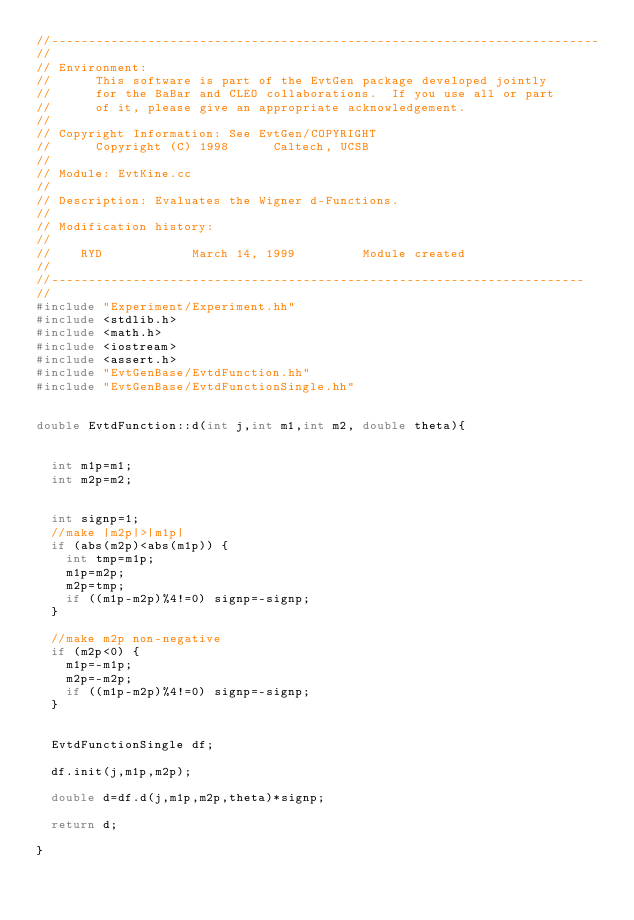Convert code to text. <code><loc_0><loc_0><loc_500><loc_500><_C++_>//--------------------------------------------------------------------------
//
// Environment:
//      This software is part of the EvtGen package developed jointly
//      for the BaBar and CLEO collaborations.  If you use all or part
//      of it, please give an appropriate acknowledgement.
//
// Copyright Information: See EvtGen/COPYRIGHT
//      Copyright (C) 1998      Caltech, UCSB
//
// Module: EvtKine.cc
//
// Description: Evaluates the Wigner d-Functions.
//
// Modification history:
//
//    RYD            March 14, 1999         Module created
//
//------------------------------------------------------------------------
// 
#include "Experiment/Experiment.hh"
#include <stdlib.h>
#include <math.h>
#include <iostream>
#include <assert.h>
#include "EvtGenBase/EvtdFunction.hh"
#include "EvtGenBase/EvtdFunctionSingle.hh"


double EvtdFunction::d(int j,int m1,int m2, double theta){


  int m1p=m1;
  int m2p=m2;


  int signp=1;
  //make |m2p|>|m1p|
  if (abs(m2p)<abs(m1p)) {
    int tmp=m1p;
    m1p=m2p;
    m2p=tmp;
    if ((m1p-m2p)%4!=0) signp=-signp;
  } 

  //make m2p non-negative
  if (m2p<0) {
    m1p=-m1p;
    m2p=-m2p;
    if ((m1p-m2p)%4!=0) signp=-signp;
  }


  EvtdFunctionSingle df;

  df.init(j,m1p,m2p);

  double d=df.d(j,m1p,m2p,theta)*signp;

  return d;
  
}



</code> 